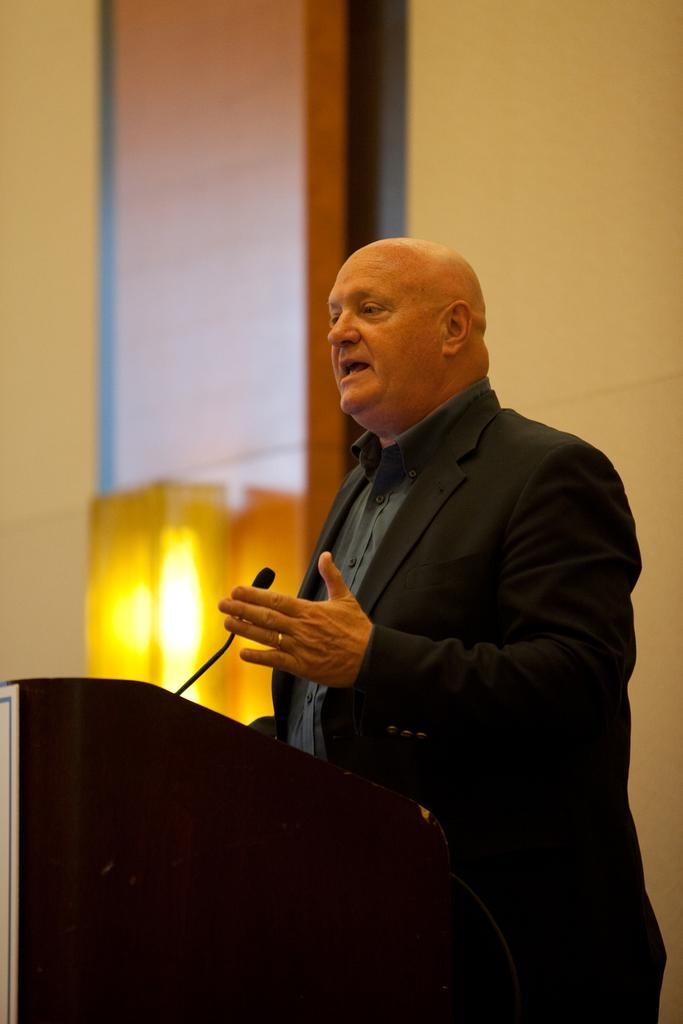What is the main subject of the image? There is a person in the image. What is the person wearing? The person is wearing a black suit. What is the person doing in the image? The person is speaking. What object is present in the image that might be used for amplifying the person's voice? There is a microphone on the podium in the image. What can be seen in the background of the image? There is a wall and light visible in the background. Can you tell me how many ants are crawling on the person's suit in the image? There are no ants visible on the person's suit in the image. What type of crayon is the person using to write on the podium? There is no crayon present in the image, and the person is speaking, not writing. 